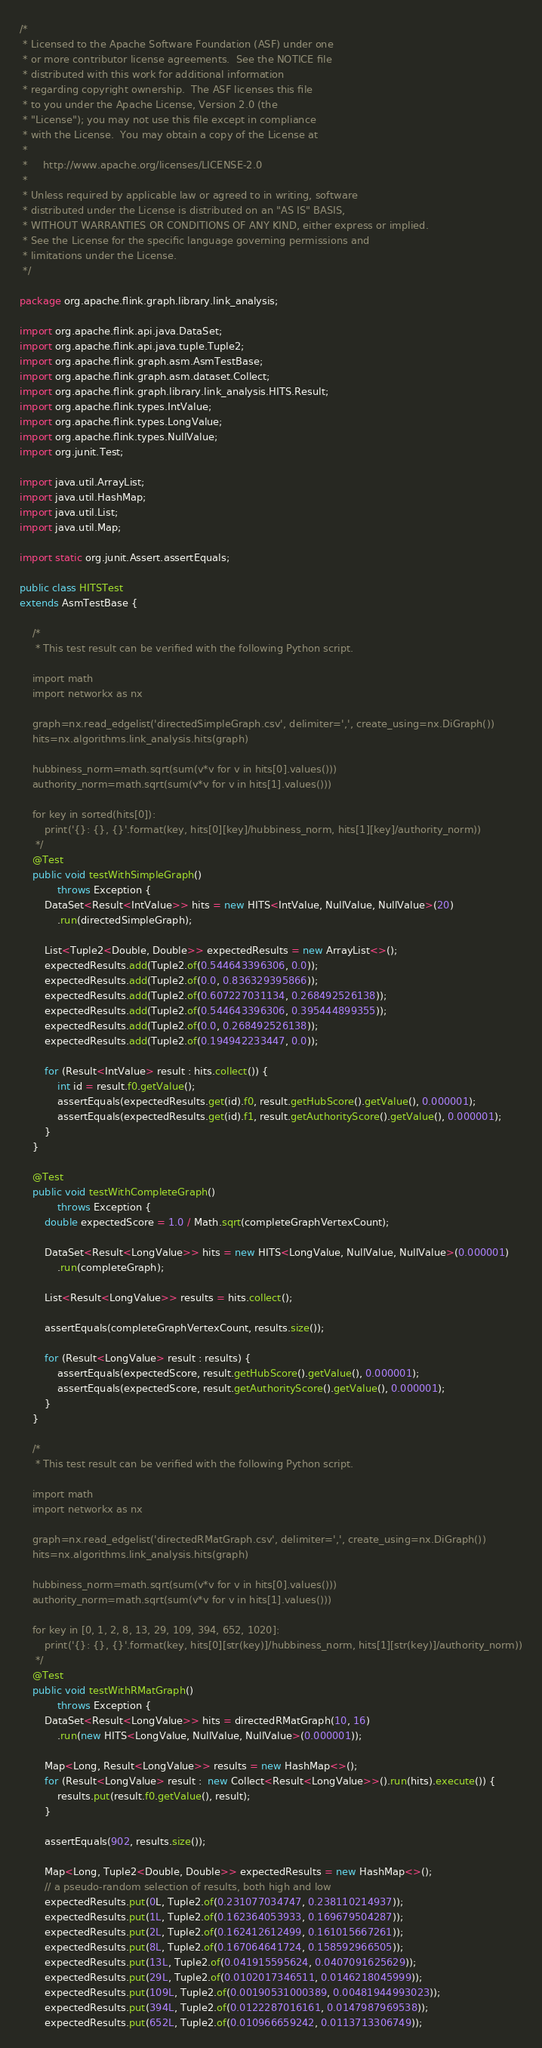<code> <loc_0><loc_0><loc_500><loc_500><_Java_>/*
 * Licensed to the Apache Software Foundation (ASF) under one
 * or more contributor license agreements.  See the NOTICE file
 * distributed with this work for additional information
 * regarding copyright ownership.  The ASF licenses this file
 * to you under the Apache License, Version 2.0 (the
 * "License"); you may not use this file except in compliance
 * with the License.  You may obtain a copy of the License at
 *
 *     http://www.apache.org/licenses/LICENSE-2.0
 *
 * Unless required by applicable law or agreed to in writing, software
 * distributed under the License is distributed on an "AS IS" BASIS,
 * WITHOUT WARRANTIES OR CONDITIONS OF ANY KIND, either express or implied.
 * See the License for the specific language governing permissions and
 * limitations under the License.
 */

package org.apache.flink.graph.library.link_analysis;

import org.apache.flink.api.java.DataSet;
import org.apache.flink.api.java.tuple.Tuple2;
import org.apache.flink.graph.asm.AsmTestBase;
import org.apache.flink.graph.asm.dataset.Collect;
import org.apache.flink.graph.library.link_analysis.HITS.Result;
import org.apache.flink.types.IntValue;
import org.apache.flink.types.LongValue;
import org.apache.flink.types.NullValue;
import org.junit.Test;

import java.util.ArrayList;
import java.util.HashMap;
import java.util.List;
import java.util.Map;

import static org.junit.Assert.assertEquals;

public class HITSTest
extends AsmTestBase {

	/*
	 * This test result can be verified with the following Python script.

	import math
	import networkx as nx

	graph=nx.read_edgelist('directedSimpleGraph.csv', delimiter=',', create_using=nx.DiGraph())
	hits=nx.algorithms.link_analysis.hits(graph)

	hubbiness_norm=math.sqrt(sum(v*v for v in hits[0].values()))
	authority_norm=math.sqrt(sum(v*v for v in hits[1].values()))

	for key in sorted(hits[0]):
		print('{}: {}, {}'.format(key, hits[0][key]/hubbiness_norm, hits[1][key]/authority_norm))
	 */
	@Test
	public void testWithSimpleGraph()
			throws Exception {
		DataSet<Result<IntValue>> hits = new HITS<IntValue, NullValue, NullValue>(20)
			.run(directedSimpleGraph);

		List<Tuple2<Double, Double>> expectedResults = new ArrayList<>();
		expectedResults.add(Tuple2.of(0.544643396306, 0.0));
		expectedResults.add(Tuple2.of(0.0, 0.836329395866));
		expectedResults.add(Tuple2.of(0.607227031134, 0.268492526138));
		expectedResults.add(Tuple2.of(0.544643396306, 0.395444899355));
		expectedResults.add(Tuple2.of(0.0, 0.268492526138));
		expectedResults.add(Tuple2.of(0.194942233447, 0.0));

		for (Result<IntValue> result : hits.collect()) {
			int id = result.f0.getValue();
			assertEquals(expectedResults.get(id).f0, result.getHubScore().getValue(), 0.000001);
			assertEquals(expectedResults.get(id).f1, result.getAuthorityScore().getValue(), 0.000001);
		}
	}

	@Test
	public void testWithCompleteGraph()
			throws Exception {
		double expectedScore = 1.0 / Math.sqrt(completeGraphVertexCount);

		DataSet<Result<LongValue>> hits = new HITS<LongValue, NullValue, NullValue>(0.000001)
			.run(completeGraph);

		List<Result<LongValue>> results = hits.collect();

		assertEquals(completeGraphVertexCount, results.size());

		for (Result<LongValue> result : results) {
			assertEquals(expectedScore, result.getHubScore().getValue(), 0.000001);
			assertEquals(expectedScore, result.getAuthorityScore().getValue(), 0.000001);
		}
	}

	/*
	 * This test result can be verified with the following Python script.

	import math
	import networkx as nx

	graph=nx.read_edgelist('directedRMatGraph.csv', delimiter=',', create_using=nx.DiGraph())
	hits=nx.algorithms.link_analysis.hits(graph)

	hubbiness_norm=math.sqrt(sum(v*v for v in hits[0].values()))
	authority_norm=math.sqrt(sum(v*v for v in hits[1].values()))

	for key in [0, 1, 2, 8, 13, 29, 109, 394, 652, 1020]:
		print('{}: {}, {}'.format(key, hits[0][str(key)]/hubbiness_norm, hits[1][str(key)]/authority_norm))
	 */
	@Test
	public void testWithRMatGraph()
			throws Exception {
		DataSet<Result<LongValue>> hits = directedRMatGraph(10, 16)
			.run(new HITS<LongValue, NullValue, NullValue>(0.000001));

		Map<Long, Result<LongValue>> results = new HashMap<>();
		for (Result<LongValue> result :  new Collect<Result<LongValue>>().run(hits).execute()) {
			results.put(result.f0.getValue(), result);
		}

		assertEquals(902, results.size());

		Map<Long, Tuple2<Double, Double>> expectedResults = new HashMap<>();
		// a pseudo-random selection of results, both high and low
		expectedResults.put(0L, Tuple2.of(0.231077034747, 0.238110214937));
		expectedResults.put(1L, Tuple2.of(0.162364053933, 0.169679504287));
		expectedResults.put(2L, Tuple2.of(0.162412612499, 0.161015667261));
		expectedResults.put(8L, Tuple2.of(0.167064641724, 0.158592966505));
		expectedResults.put(13L, Tuple2.of(0.041915595624, 0.0407091625629));
		expectedResults.put(29L, Tuple2.of(0.0102017346511, 0.0146218045999));
		expectedResults.put(109L, Tuple2.of(0.00190531000389, 0.00481944993023));
		expectedResults.put(394L, Tuple2.of(0.0122287016161, 0.0147987969538));
		expectedResults.put(652L, Tuple2.of(0.010966659242, 0.0113713306749));</code> 